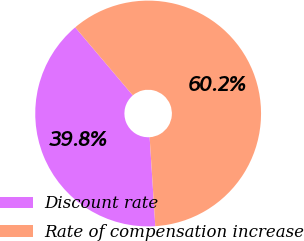<chart> <loc_0><loc_0><loc_500><loc_500><pie_chart><fcel>Discount rate<fcel>Rate of compensation increase<nl><fcel>39.83%<fcel>60.17%<nl></chart> 